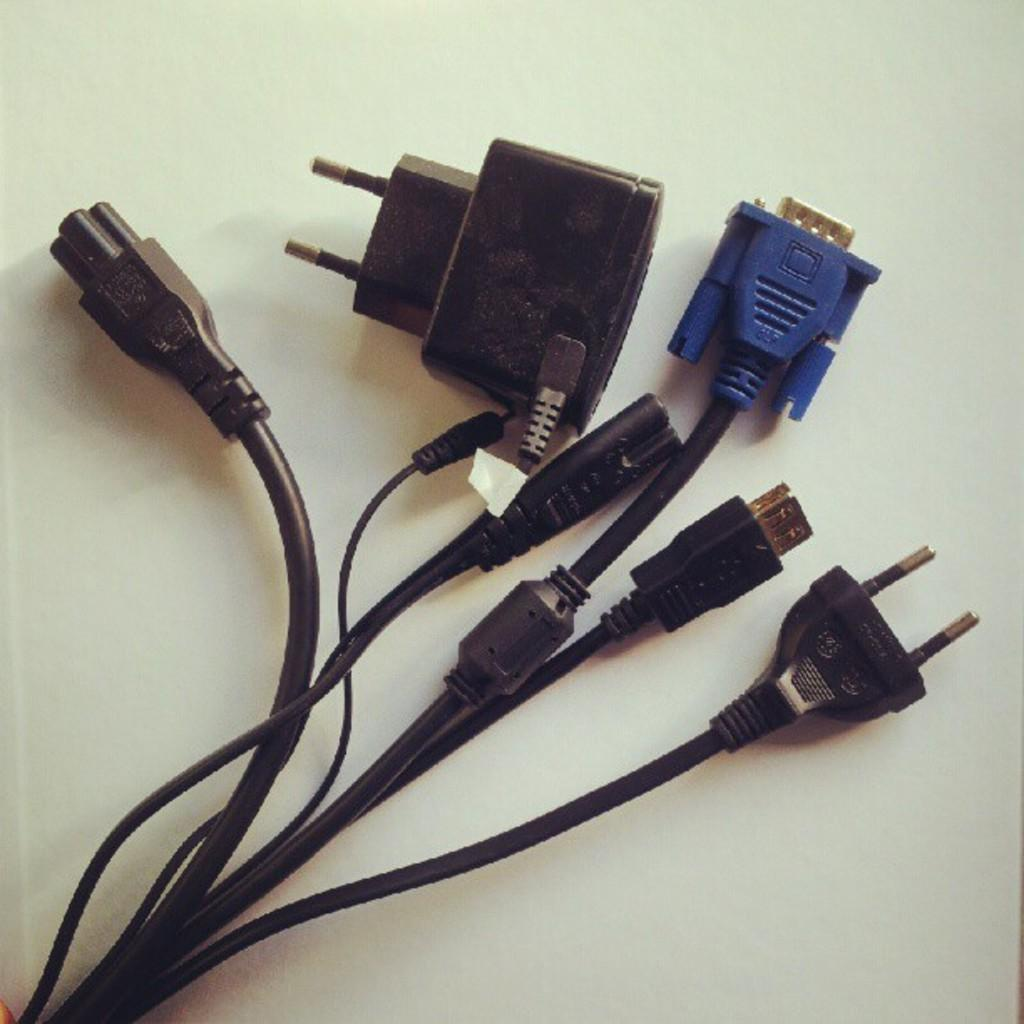What piece of furniture is present in the image? There is a table in the image. What is placed on the table? There are cable wires on the table. What type of jelly is being used to approve the ship in the image? There is no jelly, approval, or ship present in the image. 